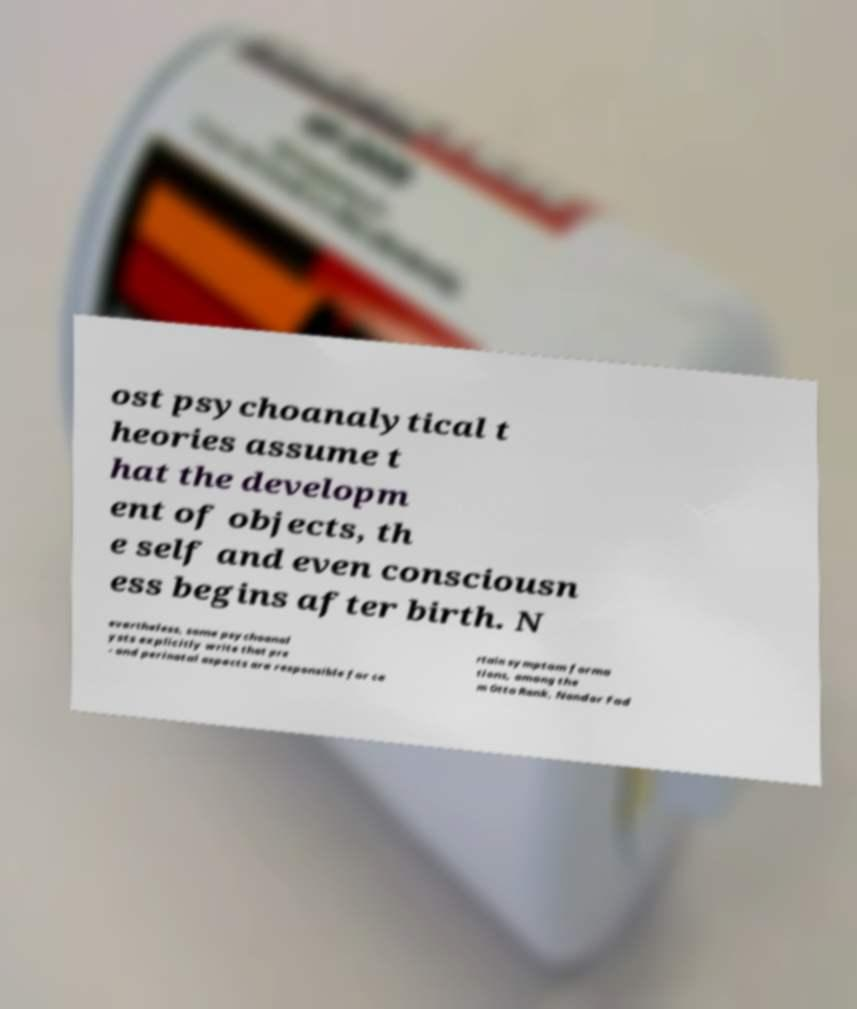Could you assist in decoding the text presented in this image and type it out clearly? ost psychoanalytical t heories assume t hat the developm ent of objects, th e self and even consciousn ess begins after birth. N evertheless, some psychoanal ysts explicitly write that pre - and perinatal aspects are responsible for ce rtain symptom forma tions, among the m Otto Rank, Nandor Fod 